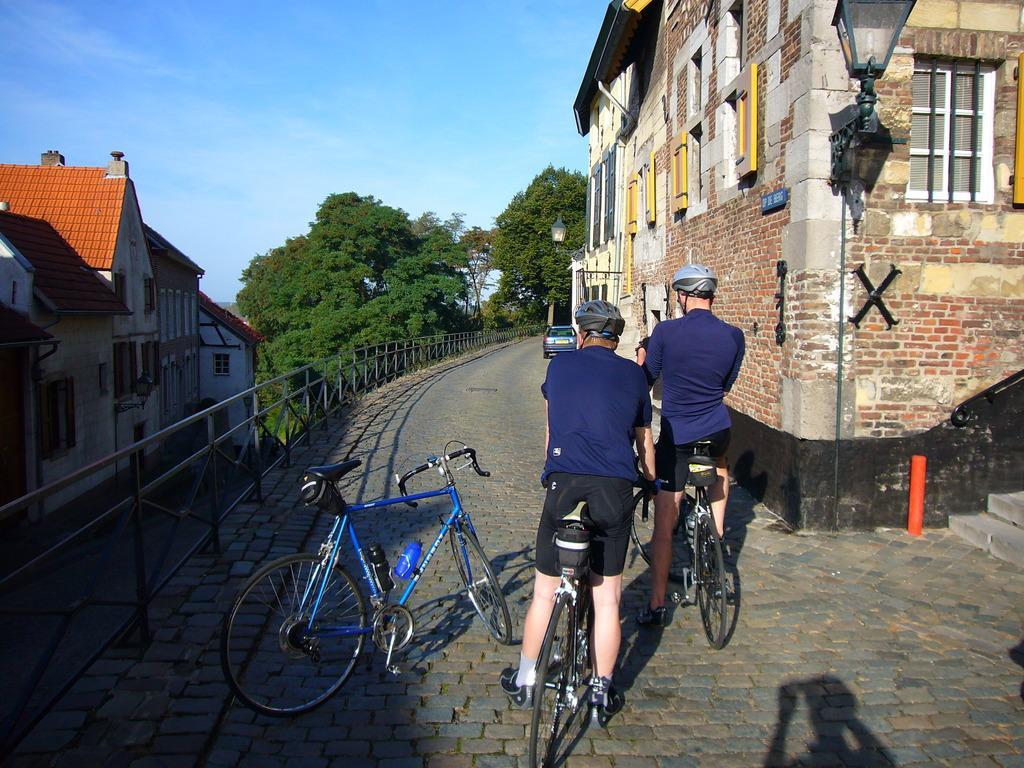Could you give a brief overview of what you see in this image? Here we can see 2 people sitting on a bicycle and beside them there is a bicycle present and at the right side we can see buildings same as on left side we can see a light post and we can see number of trees present 